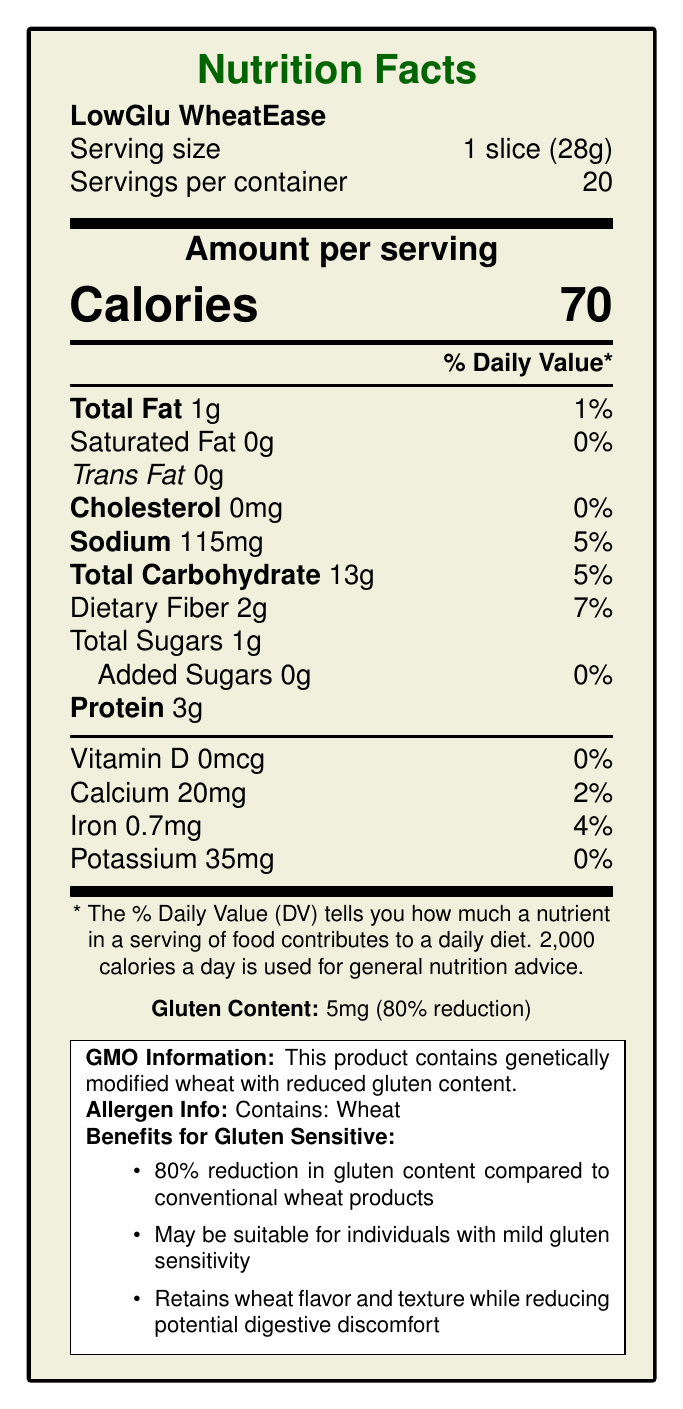What is the serving size of LowGlu WheatEase? The document specifies that the serving size of LowGlu WheatEase is 1 slice (28g).
Answer: 1 slice (28g) How many calories are there per serving? The document shows that there are 70 calories per serving.
Answer: 70 What percentage of the daily value of sodium does one serving of LowGlu WheatEase provide? The document indicates that one serving of LowGlu WheatEase provides 5% of the daily value for sodium.
Answer: 5% How much protein is in each serving? The document states that each serving contains 3g of protein.
Answer: 3g What is the total carbohydrate content per serving? The document mentions that the total carbohydrate content per serving is 13g.
Answer: 13g Which vitamin or mineral has the highest daily value percentage in this product? According to the document, dietary fiber has the highest daily value percentage at 7%.
Answer: Dietary Fiber at 7% How much gluten content is in one slice of LowGlu WheatEase? The document lists the gluten content as 5mg per slice, representing an 80% reduction.
Answer: 5mg Which of the following benefits for gluten-sensitive individuals is mentioned in the document? A. 100% gluten-free B. Suitable for celiac disease C. Reduced digestive discomfort The document states that LowGlu WheatEase retains wheat flavor and texture while reducing potential digestive discomfort, making it potentially suitable for individuals with mild gluten sensitivity.
Answer: C How many servings are there per container of LowGlu WheatEase? The document indicates that there are 20 servings per container.
Answer: 20 Does this product contain added sugars? Yes/No The document specifies that the amount of added sugars is 0g per serving.
Answer: No Summarize the main idea of the document. The document focuses on presenting the nutritional profile of a GMO wheat product with reduced gluten content and its potential benefits for gluten-sensitive individuals. It provides comprehensive details on serving size, calorie content, and various nutrient amounts, along with specific notes on gluten content and its reduction.
Answer: The document provides detailed nutrition information for LowGlu WheatEase, a GMO wheat product with reduced gluten content, highlighting its potential benefits for gluten-sensitive individuals. The product retains wheat's flavor and texture while offering 80% less gluten, which may help individuals with mild gluten sensitivity. It also includes information on calories, fats, carbohydrates, and various nutrients. Can individuals with celiac disease safely consume LowGlu WheatEase? The document notes that while LowGlu WheatEase may be suitable for individuals with mild gluten sensitivity, it is not recommended for those with celiac disease.
Answer: Not suitable for celiac disease patients What nutritional element contributes the least to the daily value in LowGlu WheatEase? A. Calcium B. Iron C. Vitamin D D. Potassium According to the document, Vitamin D contributes 0% to the daily value, which is the least compared to the other options listed.
Answer: C. Vitamin D What is the GMO information mentioned in the document? The document specifically states that LowGlu WheatEase contains genetically modified wheat with reduced gluten content.
Answer: This product contains genetically modified wheat with reduced gluten content. Which gene-editing technique was used to reduce the gluten content in LowGlu WheatEase? The document does not provide specific information about the gene-editing technique used to reduce gluten content.
Answer: Cannot be determined 